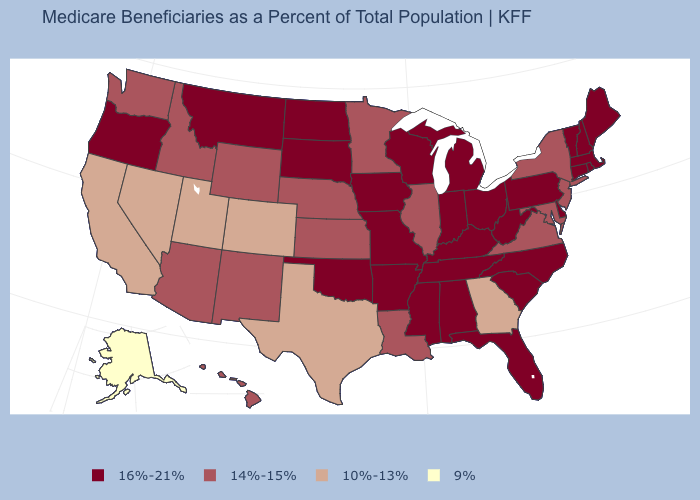What is the lowest value in states that border Maine?
Concise answer only. 16%-21%. Which states have the lowest value in the USA?
Be succinct. Alaska. Name the states that have a value in the range 10%-13%?
Write a very short answer. California, Colorado, Georgia, Nevada, Texas, Utah. Name the states that have a value in the range 10%-13%?
Keep it brief. California, Colorado, Georgia, Nevada, Texas, Utah. How many symbols are there in the legend?
Give a very brief answer. 4. What is the highest value in the USA?
Quick response, please. 16%-21%. What is the value of Nevada?
Be succinct. 10%-13%. What is the value of Arkansas?
Write a very short answer. 16%-21%. Is the legend a continuous bar?
Short answer required. No. What is the lowest value in states that border Rhode Island?
Write a very short answer. 16%-21%. Name the states that have a value in the range 10%-13%?
Write a very short answer. California, Colorado, Georgia, Nevada, Texas, Utah. What is the value of North Carolina?
Be succinct. 16%-21%. Does the first symbol in the legend represent the smallest category?
Write a very short answer. No. Among the states that border New Hampshire , which have the highest value?
Write a very short answer. Maine, Massachusetts, Vermont. Name the states that have a value in the range 10%-13%?
Be succinct. California, Colorado, Georgia, Nevada, Texas, Utah. 